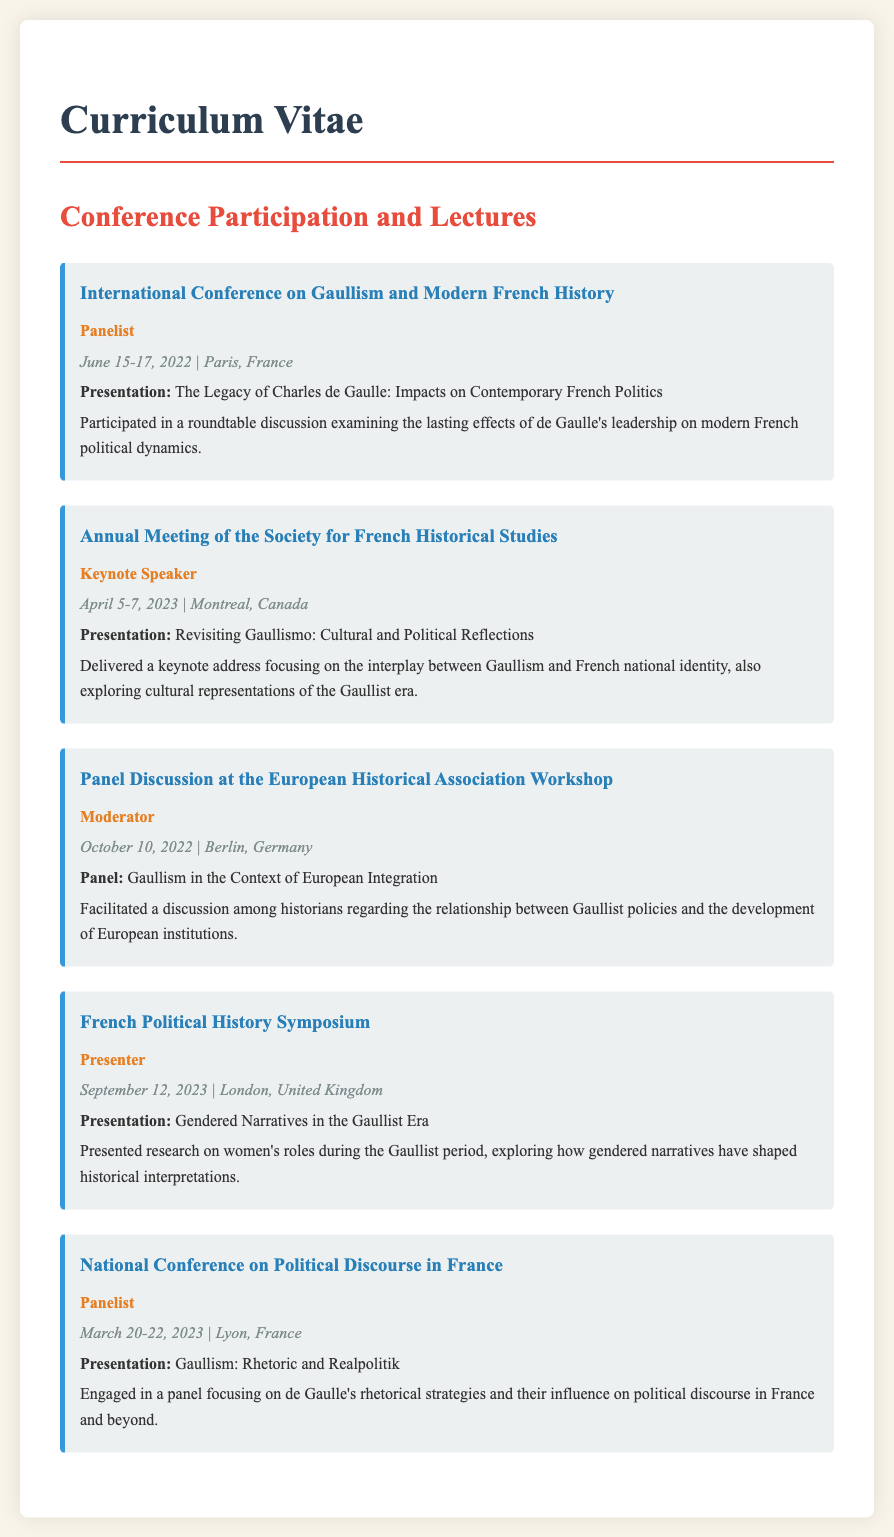What was the date of the International Conference on Gaullism and Modern French History? The date of the conference is mentioned directly in the document, which states it took place from June 15-17, 2022.
Answer: June 15-17, 2022 Who delivered the keynote address at the Annual Meeting of the Society for French Historical Studies? The document specifies that the keynote speaker at this event was Odile Rudelle.
Answer: Odile Rudelle What was the main topic of the presentation at the French Political History Symposium? The document outlines that the presentation was focused on gendered narratives during the Gaullist period.
Answer: Gendered Narratives in the Gaullist Era How many events does Odile Rudelle describe in her CV section on Conference Participation and Lectures? The document lists five distinct events that she participated in.
Answer: Five What role did Odile Rudelle hold during the panel discussion at the European Historical Association Workshop? The document indicates that she was the moderator of the discussion.
Answer: Moderator What city hosted the National Conference on Political Discourse in France? The document states that this conference occurred in Lyon, France.
Answer: Lyon, France What specific aspect of Gaullism was discussed in the panel titled "Gaullism in the Context of European Integration"? The document reveals that the discussion focused on the relationship between Gaullist policies and European institutions.
Answer: Relationship between Gaullist policies and European institutions Which conference had a presentation that explored women's roles during the Gaullist period? According to the document, the French Political History Symposium featured this presentation.
Answer: French Political History Symposium 